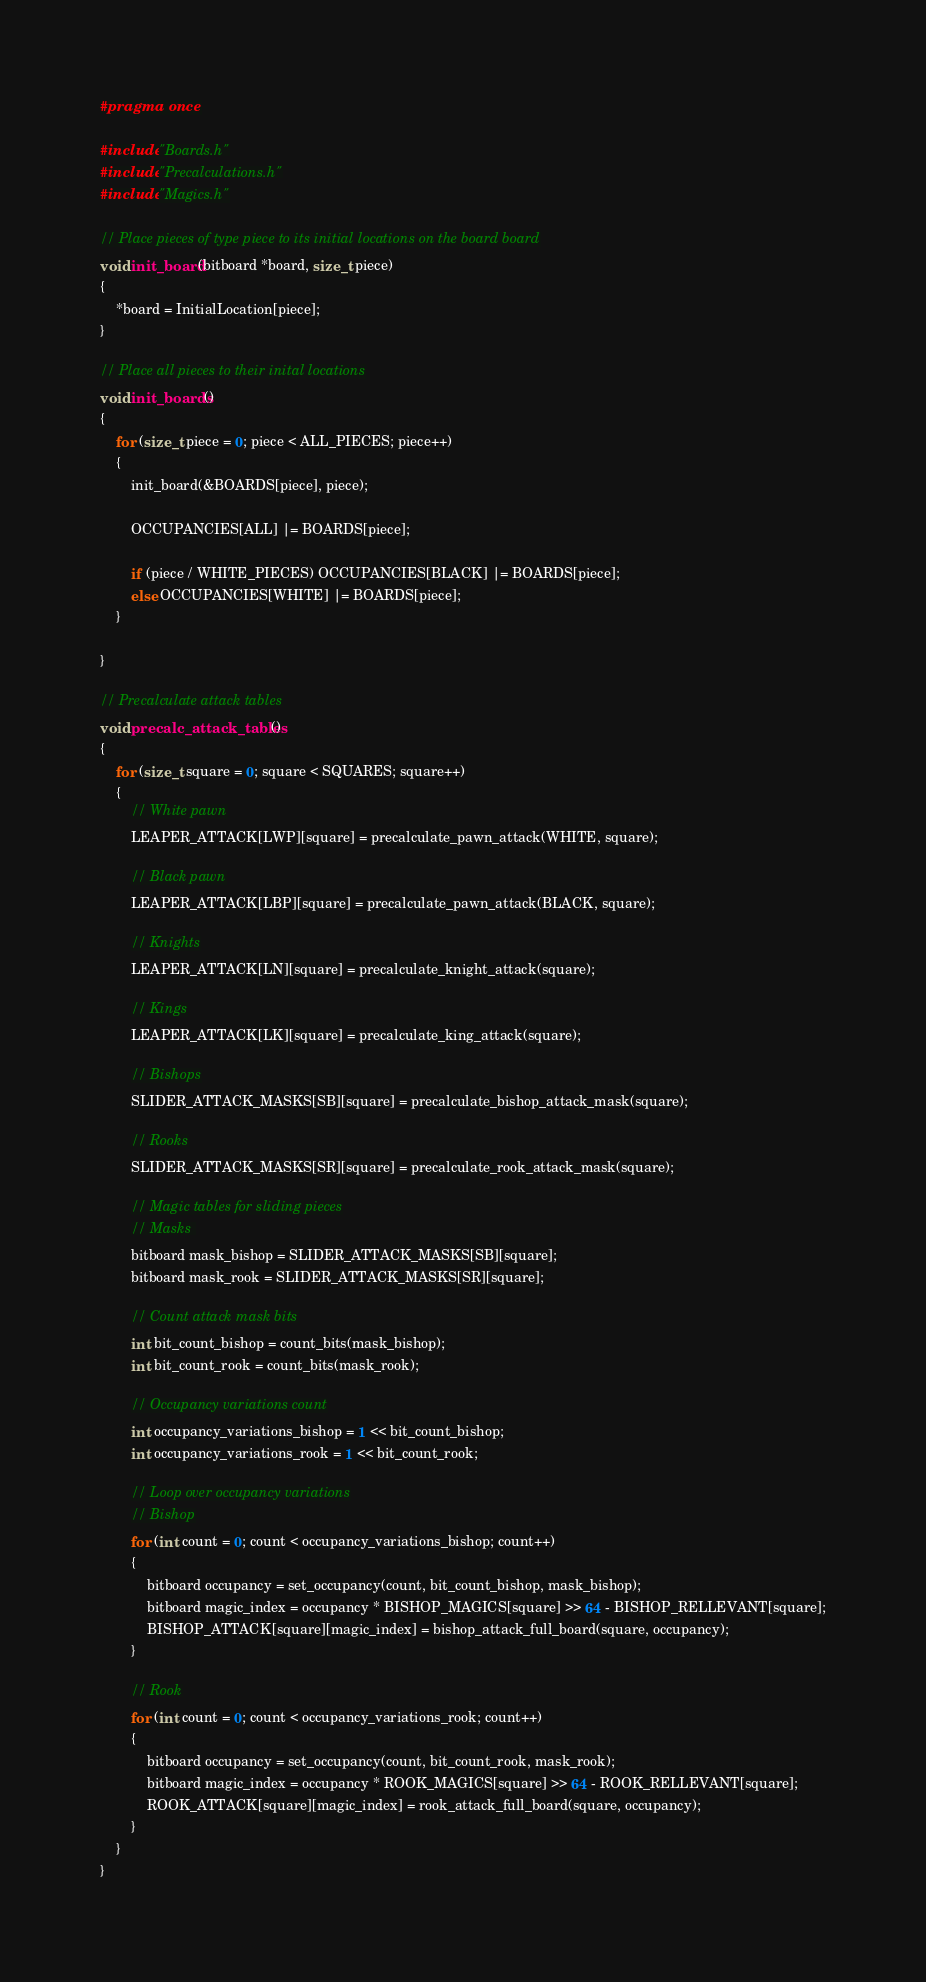Convert code to text. <code><loc_0><loc_0><loc_500><loc_500><_C_>#pragma once

#include "Boards.h"
#include "Precalculations.h"
#include "Magics.h"

// Place pieces of type piece to its initial locations on the board board
void init_board(bitboard *board, size_t piece)
{
	*board = InitialLocation[piece];
}

// Place all pieces to their inital locations
void init_boards()
{
    for (size_t piece = 0; piece < ALL_PIECES; piece++)
    {
		init_board(&BOARDS[piece], piece);
        
        OCCUPANCIES[ALL] |= BOARDS[piece];

        if (piece / WHITE_PIECES) OCCUPANCIES[BLACK] |= BOARDS[piece];
        else OCCUPANCIES[WHITE] |= BOARDS[piece];
    }

}

// Precalculate attack tables
void precalc_attack_tables()
{
	for (size_t square = 0; square < SQUARES; square++)
	{
		// White pawn
		LEAPER_ATTACK[LWP][square] = precalculate_pawn_attack(WHITE, square);

		// Black pawn
		LEAPER_ATTACK[LBP][square] = precalculate_pawn_attack(BLACK, square);

		// Knights
		LEAPER_ATTACK[LN][square] = precalculate_knight_attack(square);

		// Kings
		LEAPER_ATTACK[LK][square] = precalculate_king_attack(square);

		// Bishops
		SLIDER_ATTACK_MASKS[SB][square] = precalculate_bishop_attack_mask(square);

		// Rooks
		SLIDER_ATTACK_MASKS[SR][square] = precalculate_rook_attack_mask(square);

		// Magic tables for sliding pieces
        // Masks 
        bitboard mask_bishop = SLIDER_ATTACK_MASKS[SB][square];
        bitboard mask_rook = SLIDER_ATTACK_MASKS[SR][square];

        // Count attack mask bits
        int bit_count_bishop = count_bits(mask_bishop);
        int bit_count_rook = count_bits(mask_rook);

        // Occupancy variations count
        int occupancy_variations_bishop = 1 << bit_count_bishop;
        int occupancy_variations_rook = 1 << bit_count_rook;

        // Loop over occupancy variations
        // Bishop
        for (int count = 0; count < occupancy_variations_bishop; count++)
        {
            bitboard occupancy = set_occupancy(count, bit_count_bishop, mask_bishop);
            bitboard magic_index = occupancy * BISHOP_MAGICS[square] >> 64 - BISHOP_RELLEVANT[square];
            BISHOP_ATTACK[square][magic_index] = bishop_attack_full_board(square, occupancy);
        }

        // Rook
        for (int count = 0; count < occupancy_variations_rook; count++)
        {
            bitboard occupancy = set_occupancy(count, bit_count_rook, mask_rook);
            bitboard magic_index = occupancy * ROOK_MAGICS[square] >> 64 - ROOK_RELLEVANT[square];
            ROOK_ATTACK[square][magic_index] = rook_attack_full_board(square, occupancy);
        }
	}
}</code> 